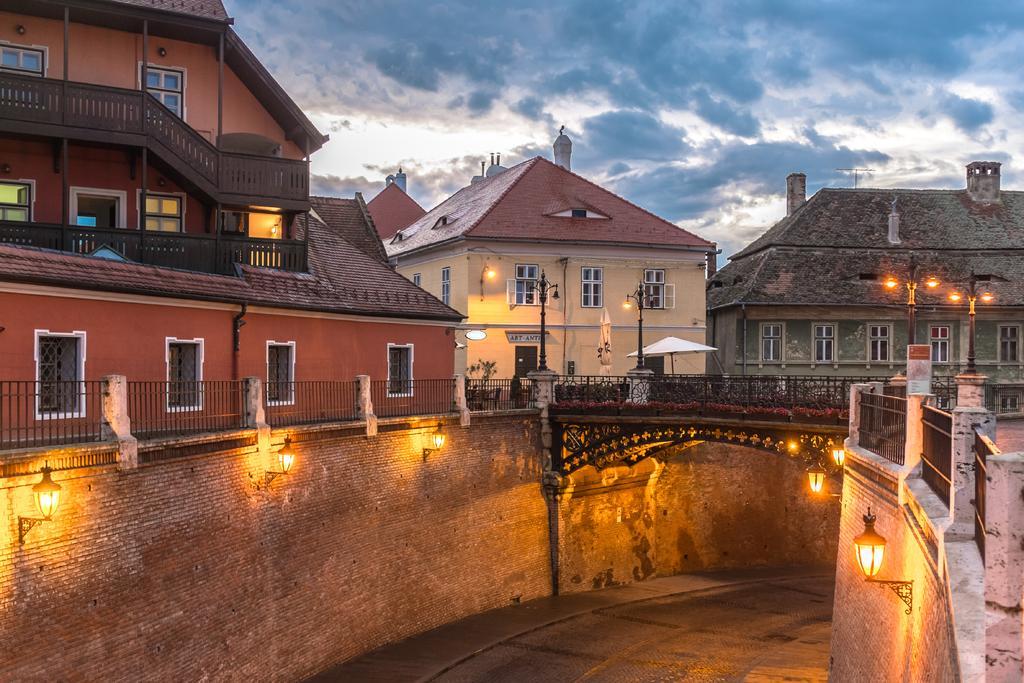In one or two sentences, can you explain what this image depicts? This is the road, there are lights, these are the buildings. At the top it is the sky. 